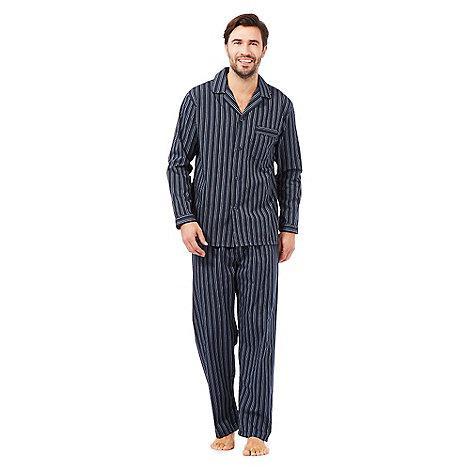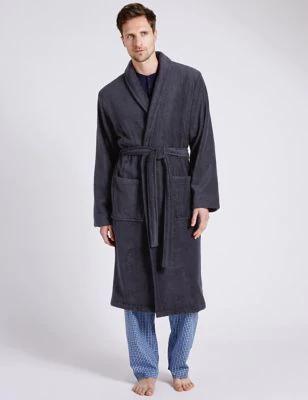The first image is the image on the left, the second image is the image on the right. Given the left and right images, does the statement "All photos are full length shots of people modeling clothes." hold true? Answer yes or no. Yes. 